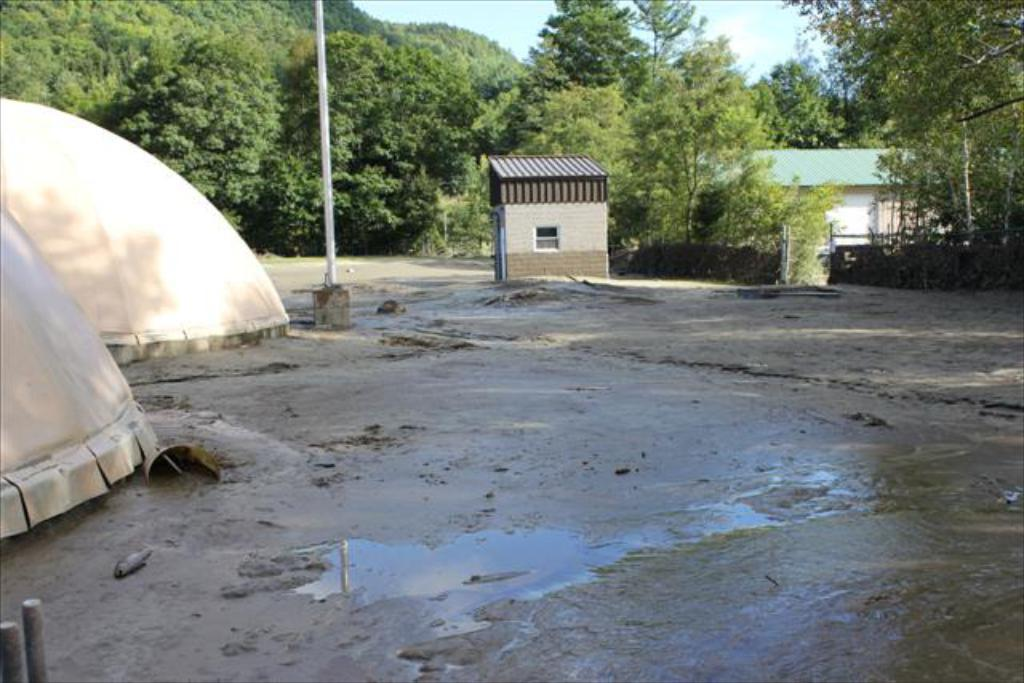What type of terrain is depicted in the image? There is mud in the image, suggesting a potentially wet or marshy area. What type of structures are present in the image? There are tents, poles, and sheds in the image. What type of vegetation is visible in the image? There are trees in the image. What is visible in the background of the image? The sky is visible in the background of the image. How many eggs are visible in the image? There are no eggs present in the image. What type of corn is growing near the tents in the image? There is no corn present in the image. 